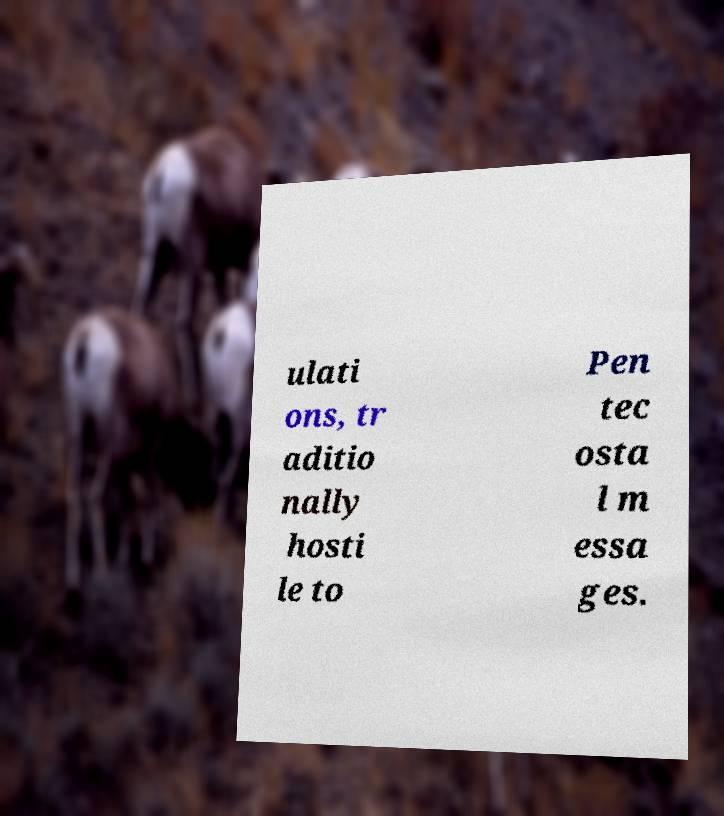Can you accurately transcribe the text from the provided image for me? ulati ons, tr aditio nally hosti le to Pen tec osta l m essa ges. 